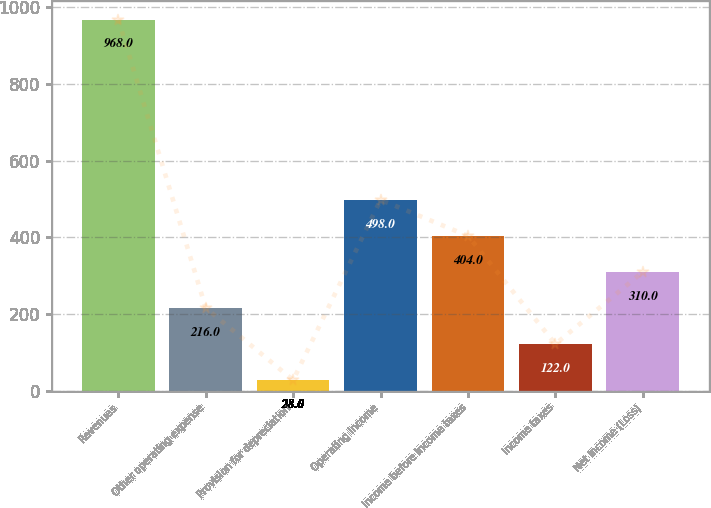Convert chart to OTSL. <chart><loc_0><loc_0><loc_500><loc_500><bar_chart><fcel>Revenues<fcel>Other operating expense<fcel>Provision for depreciation<fcel>Operating Income<fcel>Income before income taxes<fcel>Income taxes<fcel>Net Income (Loss)<nl><fcel>968<fcel>216<fcel>28<fcel>498<fcel>404<fcel>122<fcel>310<nl></chart> 